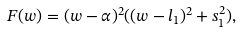Convert formula to latex. <formula><loc_0><loc_0><loc_500><loc_500>F ( w ) = ( w - \alpha ) ^ { 2 } ( ( w - l _ { 1 } ) ^ { 2 } + s _ { 1 } ^ { 2 } ) ,</formula> 